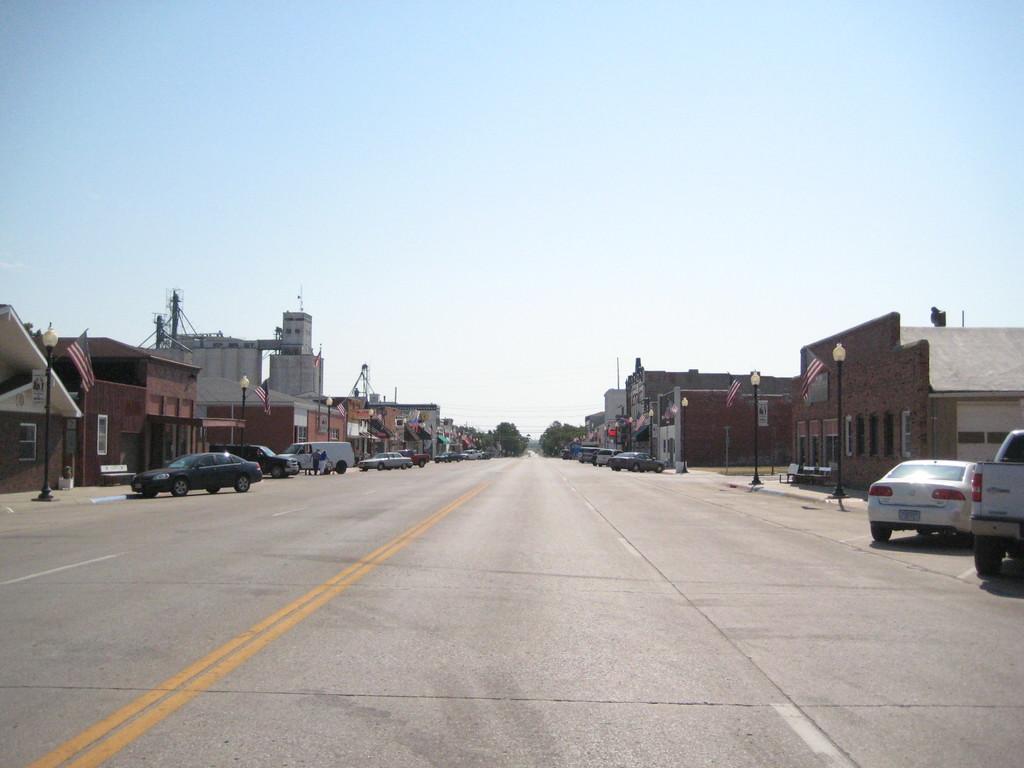Can you describe this image briefly? There is a road. On the sides of the road there are vehicles, buildings, light poles and flags. On the buildings there are windows. In the background there is sky. 